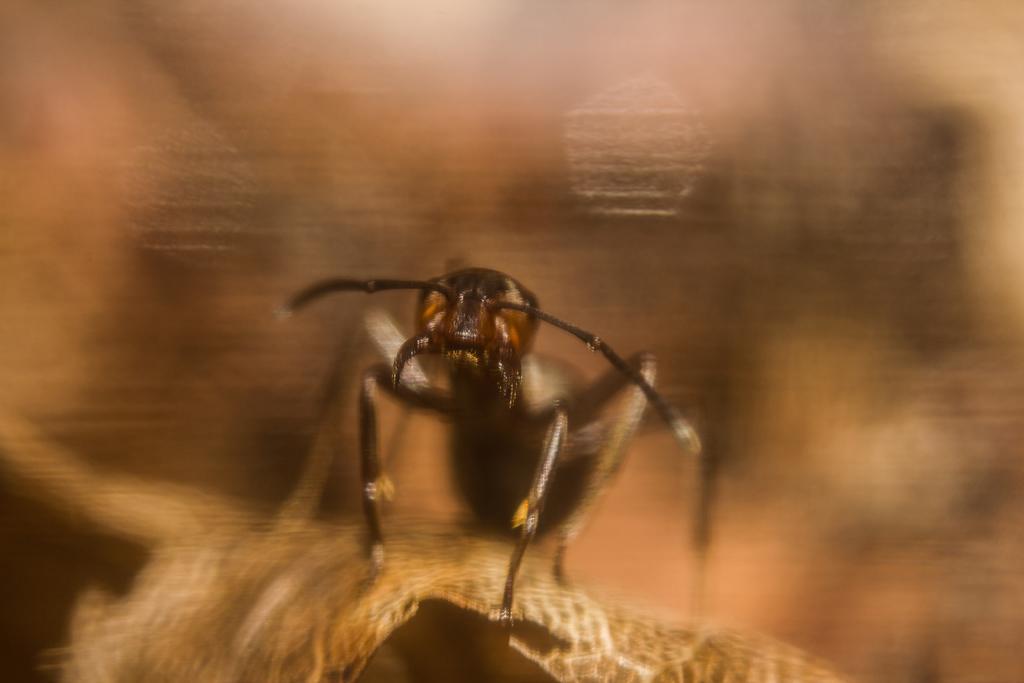How would you summarize this image in a sentence or two? In this image I can see a black colour insect in the front. I can also see this image is little bit blurry. 